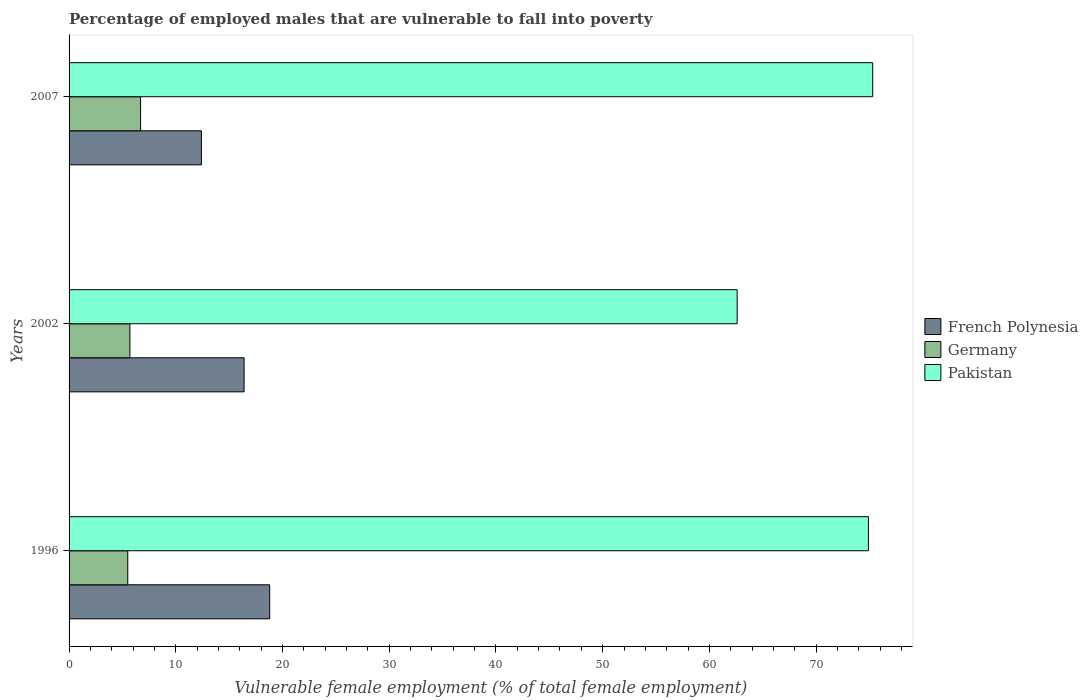How many groups of bars are there?
Make the answer very short. 3. How many bars are there on the 1st tick from the top?
Offer a very short reply. 3. How many bars are there on the 2nd tick from the bottom?
Make the answer very short. 3. What is the label of the 2nd group of bars from the top?
Make the answer very short. 2002. In how many cases, is the number of bars for a given year not equal to the number of legend labels?
Give a very brief answer. 0. What is the percentage of employed males who are vulnerable to fall into poverty in Pakistan in 2002?
Your answer should be very brief. 62.6. Across all years, what is the maximum percentage of employed males who are vulnerable to fall into poverty in Germany?
Provide a succinct answer. 6.7. Across all years, what is the minimum percentage of employed males who are vulnerable to fall into poverty in Pakistan?
Your response must be concise. 62.6. What is the total percentage of employed males who are vulnerable to fall into poverty in Germany in the graph?
Ensure brevity in your answer.  17.9. What is the difference between the percentage of employed males who are vulnerable to fall into poverty in Germany in 1996 and that in 2007?
Offer a terse response. -1.2. What is the difference between the percentage of employed males who are vulnerable to fall into poverty in Pakistan in 1996 and the percentage of employed males who are vulnerable to fall into poverty in Germany in 2007?
Keep it short and to the point. 68.2. What is the average percentage of employed males who are vulnerable to fall into poverty in Pakistan per year?
Your answer should be compact. 70.93. In the year 2007, what is the difference between the percentage of employed males who are vulnerable to fall into poverty in French Polynesia and percentage of employed males who are vulnerable to fall into poverty in Germany?
Keep it short and to the point. 5.7. In how many years, is the percentage of employed males who are vulnerable to fall into poverty in Germany greater than 62 %?
Provide a short and direct response. 0. What is the ratio of the percentage of employed males who are vulnerable to fall into poverty in French Polynesia in 1996 to that in 2007?
Provide a short and direct response. 1.52. Is the difference between the percentage of employed males who are vulnerable to fall into poverty in French Polynesia in 2002 and 2007 greater than the difference between the percentage of employed males who are vulnerable to fall into poverty in Germany in 2002 and 2007?
Your response must be concise. Yes. What is the difference between the highest and the second highest percentage of employed males who are vulnerable to fall into poverty in Pakistan?
Provide a succinct answer. 0.4. What is the difference between the highest and the lowest percentage of employed males who are vulnerable to fall into poverty in French Polynesia?
Give a very brief answer. 6.4. In how many years, is the percentage of employed males who are vulnerable to fall into poverty in Pakistan greater than the average percentage of employed males who are vulnerable to fall into poverty in Pakistan taken over all years?
Give a very brief answer. 2. Is the sum of the percentage of employed males who are vulnerable to fall into poverty in Germany in 2002 and 2007 greater than the maximum percentage of employed males who are vulnerable to fall into poverty in French Polynesia across all years?
Keep it short and to the point. No. What does the 3rd bar from the bottom in 2002 represents?
Your response must be concise. Pakistan. Are all the bars in the graph horizontal?
Keep it short and to the point. Yes. How many years are there in the graph?
Your answer should be compact. 3. What is the difference between two consecutive major ticks on the X-axis?
Provide a short and direct response. 10. Does the graph contain grids?
Offer a terse response. No. How are the legend labels stacked?
Your response must be concise. Vertical. What is the title of the graph?
Give a very brief answer. Percentage of employed males that are vulnerable to fall into poverty. Does "Mauritius" appear as one of the legend labels in the graph?
Keep it short and to the point. No. What is the label or title of the X-axis?
Provide a short and direct response. Vulnerable female employment (% of total female employment). What is the Vulnerable female employment (% of total female employment) in French Polynesia in 1996?
Ensure brevity in your answer.  18.8. What is the Vulnerable female employment (% of total female employment) of Pakistan in 1996?
Provide a short and direct response. 74.9. What is the Vulnerable female employment (% of total female employment) in French Polynesia in 2002?
Your response must be concise. 16.4. What is the Vulnerable female employment (% of total female employment) of Germany in 2002?
Make the answer very short. 5.7. What is the Vulnerable female employment (% of total female employment) of Pakistan in 2002?
Your response must be concise. 62.6. What is the Vulnerable female employment (% of total female employment) in French Polynesia in 2007?
Your response must be concise. 12.4. What is the Vulnerable female employment (% of total female employment) of Germany in 2007?
Your response must be concise. 6.7. What is the Vulnerable female employment (% of total female employment) in Pakistan in 2007?
Ensure brevity in your answer.  75.3. Across all years, what is the maximum Vulnerable female employment (% of total female employment) of French Polynesia?
Ensure brevity in your answer.  18.8. Across all years, what is the maximum Vulnerable female employment (% of total female employment) in Germany?
Provide a succinct answer. 6.7. Across all years, what is the maximum Vulnerable female employment (% of total female employment) of Pakistan?
Ensure brevity in your answer.  75.3. Across all years, what is the minimum Vulnerable female employment (% of total female employment) in French Polynesia?
Your answer should be compact. 12.4. Across all years, what is the minimum Vulnerable female employment (% of total female employment) in Germany?
Your answer should be compact. 5.5. Across all years, what is the minimum Vulnerable female employment (% of total female employment) of Pakistan?
Keep it short and to the point. 62.6. What is the total Vulnerable female employment (% of total female employment) in French Polynesia in the graph?
Provide a succinct answer. 47.6. What is the total Vulnerable female employment (% of total female employment) in Pakistan in the graph?
Provide a short and direct response. 212.8. What is the difference between the Vulnerable female employment (% of total female employment) of French Polynesia in 1996 and that in 2002?
Offer a very short reply. 2.4. What is the difference between the Vulnerable female employment (% of total female employment) in Pakistan in 1996 and that in 2007?
Offer a terse response. -0.4. What is the difference between the Vulnerable female employment (% of total female employment) of French Polynesia in 2002 and that in 2007?
Ensure brevity in your answer.  4. What is the difference between the Vulnerable female employment (% of total female employment) of Pakistan in 2002 and that in 2007?
Give a very brief answer. -12.7. What is the difference between the Vulnerable female employment (% of total female employment) of French Polynesia in 1996 and the Vulnerable female employment (% of total female employment) of Pakistan in 2002?
Give a very brief answer. -43.8. What is the difference between the Vulnerable female employment (% of total female employment) of Germany in 1996 and the Vulnerable female employment (% of total female employment) of Pakistan in 2002?
Make the answer very short. -57.1. What is the difference between the Vulnerable female employment (% of total female employment) in French Polynesia in 1996 and the Vulnerable female employment (% of total female employment) in Germany in 2007?
Keep it short and to the point. 12.1. What is the difference between the Vulnerable female employment (% of total female employment) in French Polynesia in 1996 and the Vulnerable female employment (% of total female employment) in Pakistan in 2007?
Provide a short and direct response. -56.5. What is the difference between the Vulnerable female employment (% of total female employment) in Germany in 1996 and the Vulnerable female employment (% of total female employment) in Pakistan in 2007?
Your response must be concise. -69.8. What is the difference between the Vulnerable female employment (% of total female employment) of French Polynesia in 2002 and the Vulnerable female employment (% of total female employment) of Pakistan in 2007?
Give a very brief answer. -58.9. What is the difference between the Vulnerable female employment (% of total female employment) in Germany in 2002 and the Vulnerable female employment (% of total female employment) in Pakistan in 2007?
Ensure brevity in your answer.  -69.6. What is the average Vulnerable female employment (% of total female employment) of French Polynesia per year?
Your answer should be compact. 15.87. What is the average Vulnerable female employment (% of total female employment) of Germany per year?
Ensure brevity in your answer.  5.97. What is the average Vulnerable female employment (% of total female employment) of Pakistan per year?
Your answer should be very brief. 70.93. In the year 1996, what is the difference between the Vulnerable female employment (% of total female employment) in French Polynesia and Vulnerable female employment (% of total female employment) in Pakistan?
Give a very brief answer. -56.1. In the year 1996, what is the difference between the Vulnerable female employment (% of total female employment) in Germany and Vulnerable female employment (% of total female employment) in Pakistan?
Provide a succinct answer. -69.4. In the year 2002, what is the difference between the Vulnerable female employment (% of total female employment) in French Polynesia and Vulnerable female employment (% of total female employment) in Pakistan?
Keep it short and to the point. -46.2. In the year 2002, what is the difference between the Vulnerable female employment (% of total female employment) in Germany and Vulnerable female employment (% of total female employment) in Pakistan?
Provide a succinct answer. -56.9. In the year 2007, what is the difference between the Vulnerable female employment (% of total female employment) in French Polynesia and Vulnerable female employment (% of total female employment) in Pakistan?
Provide a succinct answer. -62.9. In the year 2007, what is the difference between the Vulnerable female employment (% of total female employment) in Germany and Vulnerable female employment (% of total female employment) in Pakistan?
Your answer should be compact. -68.6. What is the ratio of the Vulnerable female employment (% of total female employment) in French Polynesia in 1996 to that in 2002?
Your response must be concise. 1.15. What is the ratio of the Vulnerable female employment (% of total female employment) in Germany in 1996 to that in 2002?
Your response must be concise. 0.96. What is the ratio of the Vulnerable female employment (% of total female employment) in Pakistan in 1996 to that in 2002?
Ensure brevity in your answer.  1.2. What is the ratio of the Vulnerable female employment (% of total female employment) in French Polynesia in 1996 to that in 2007?
Your answer should be compact. 1.52. What is the ratio of the Vulnerable female employment (% of total female employment) of Germany in 1996 to that in 2007?
Your response must be concise. 0.82. What is the ratio of the Vulnerable female employment (% of total female employment) of French Polynesia in 2002 to that in 2007?
Provide a short and direct response. 1.32. What is the ratio of the Vulnerable female employment (% of total female employment) of Germany in 2002 to that in 2007?
Keep it short and to the point. 0.85. What is the ratio of the Vulnerable female employment (% of total female employment) of Pakistan in 2002 to that in 2007?
Ensure brevity in your answer.  0.83. What is the difference between the highest and the second highest Vulnerable female employment (% of total female employment) in Pakistan?
Offer a terse response. 0.4. What is the difference between the highest and the lowest Vulnerable female employment (% of total female employment) in French Polynesia?
Provide a succinct answer. 6.4. What is the difference between the highest and the lowest Vulnerable female employment (% of total female employment) of Germany?
Provide a succinct answer. 1.2. What is the difference between the highest and the lowest Vulnerable female employment (% of total female employment) of Pakistan?
Provide a short and direct response. 12.7. 